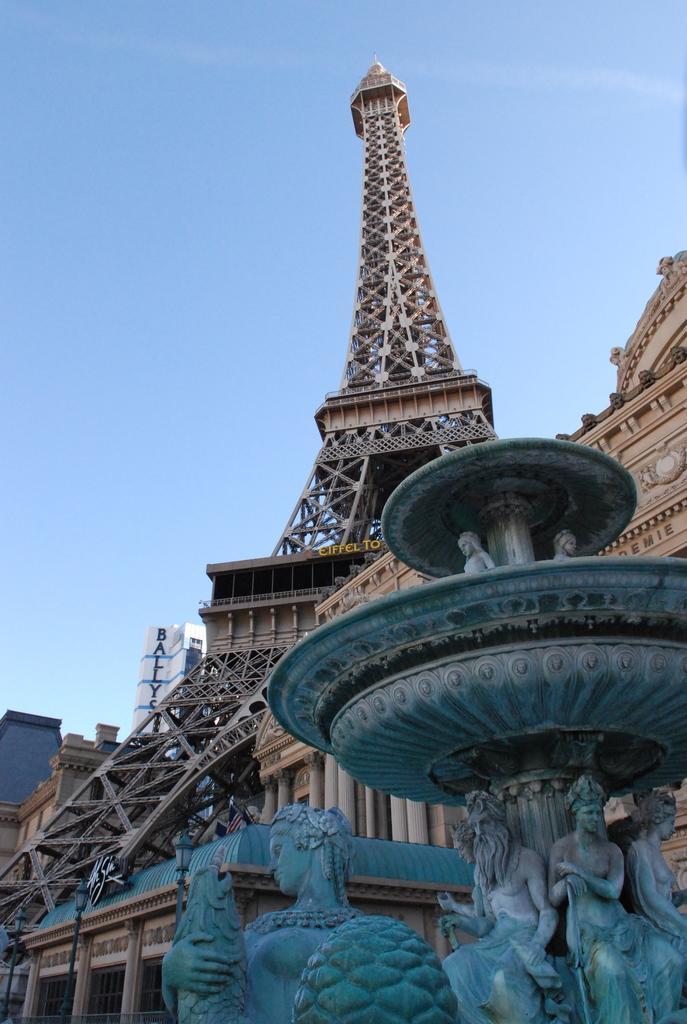Can you describe this image briefly? In the picture we can see a sculptural fountain and behind it, we can see a palace with some pillars to it and behind it, we can see an Eiffel tower and in the background we can see some buildings, and sky. 